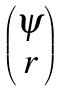<formula> <loc_0><loc_0><loc_500><loc_500>\begin{pmatrix} \psi \\ r \end{pmatrix}</formula> 